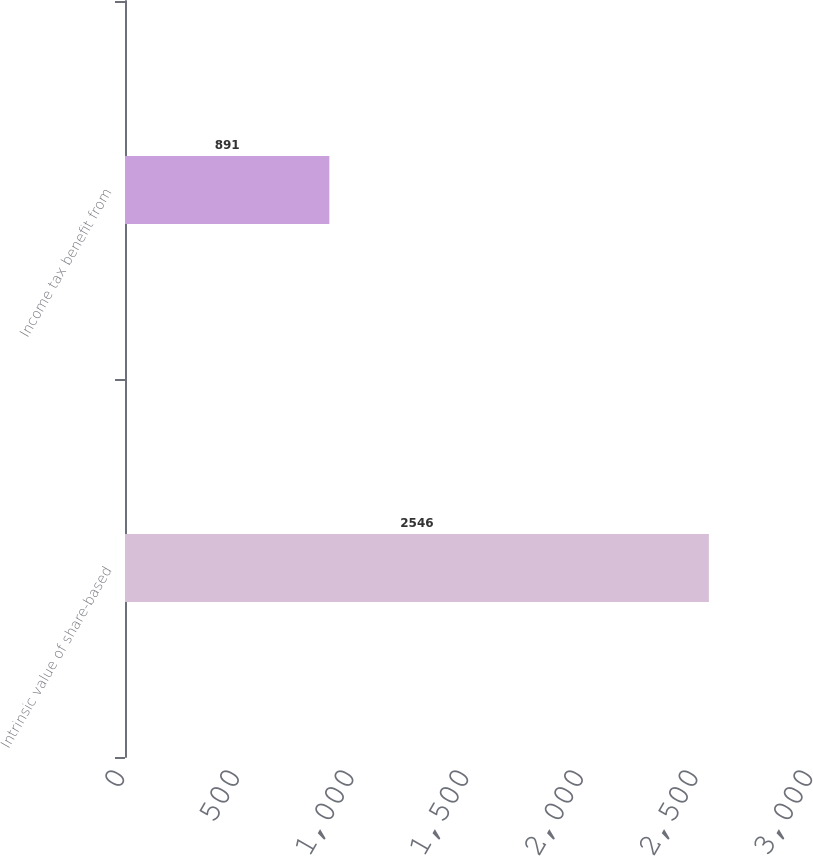Convert chart to OTSL. <chart><loc_0><loc_0><loc_500><loc_500><bar_chart><fcel>Intrinsic value of share-based<fcel>Income tax benefit from<nl><fcel>2546<fcel>891<nl></chart> 